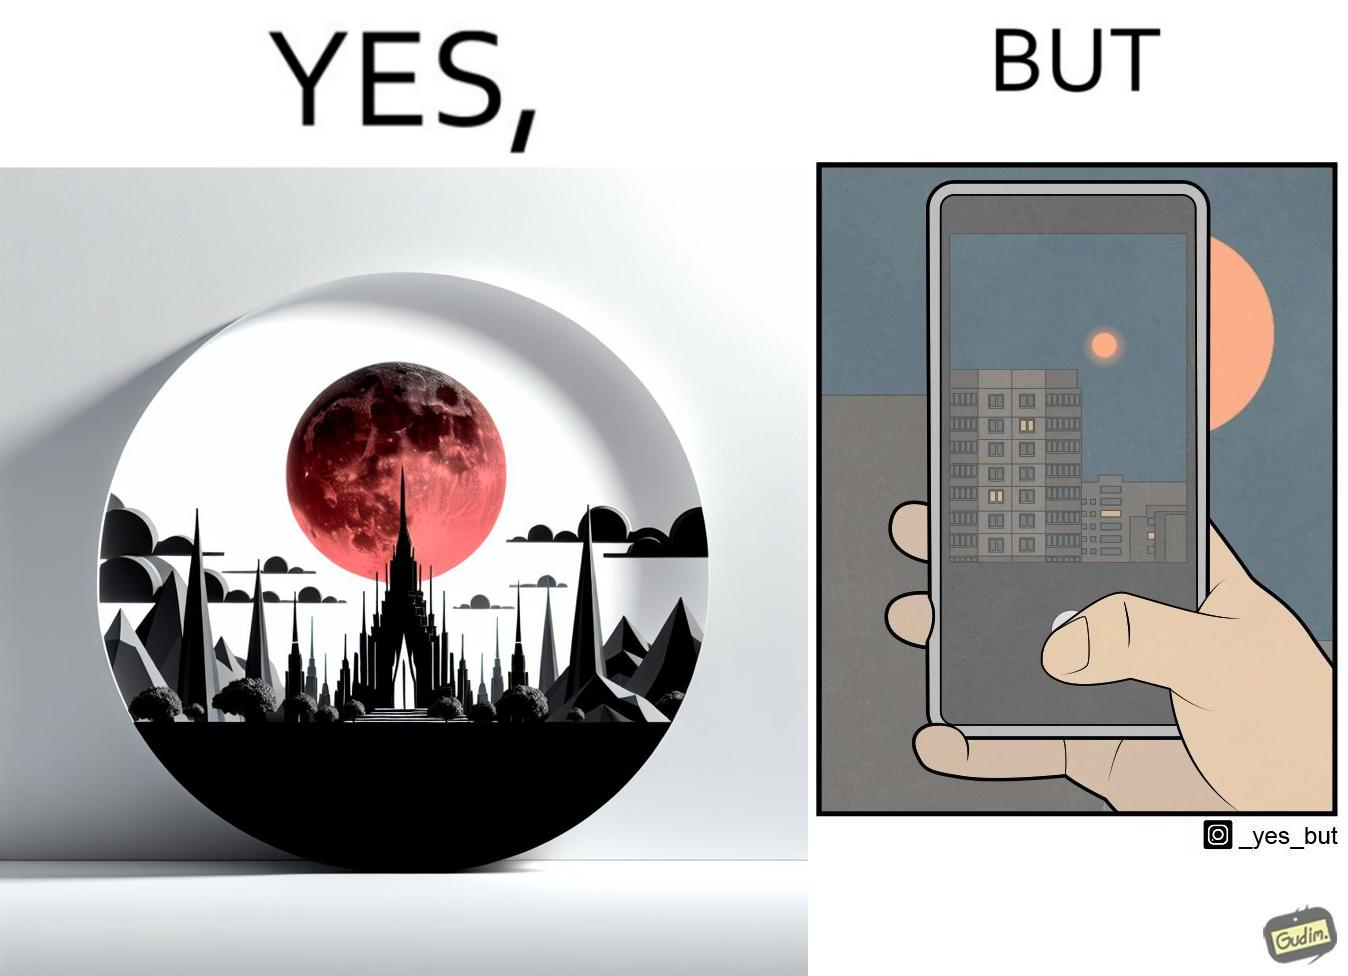What is shown in the left half versus the right half of this image? In the left part of the image: a beautiful view of red moon around a building In the right part of the image: a person trying to capture an image of red moon using his phone 